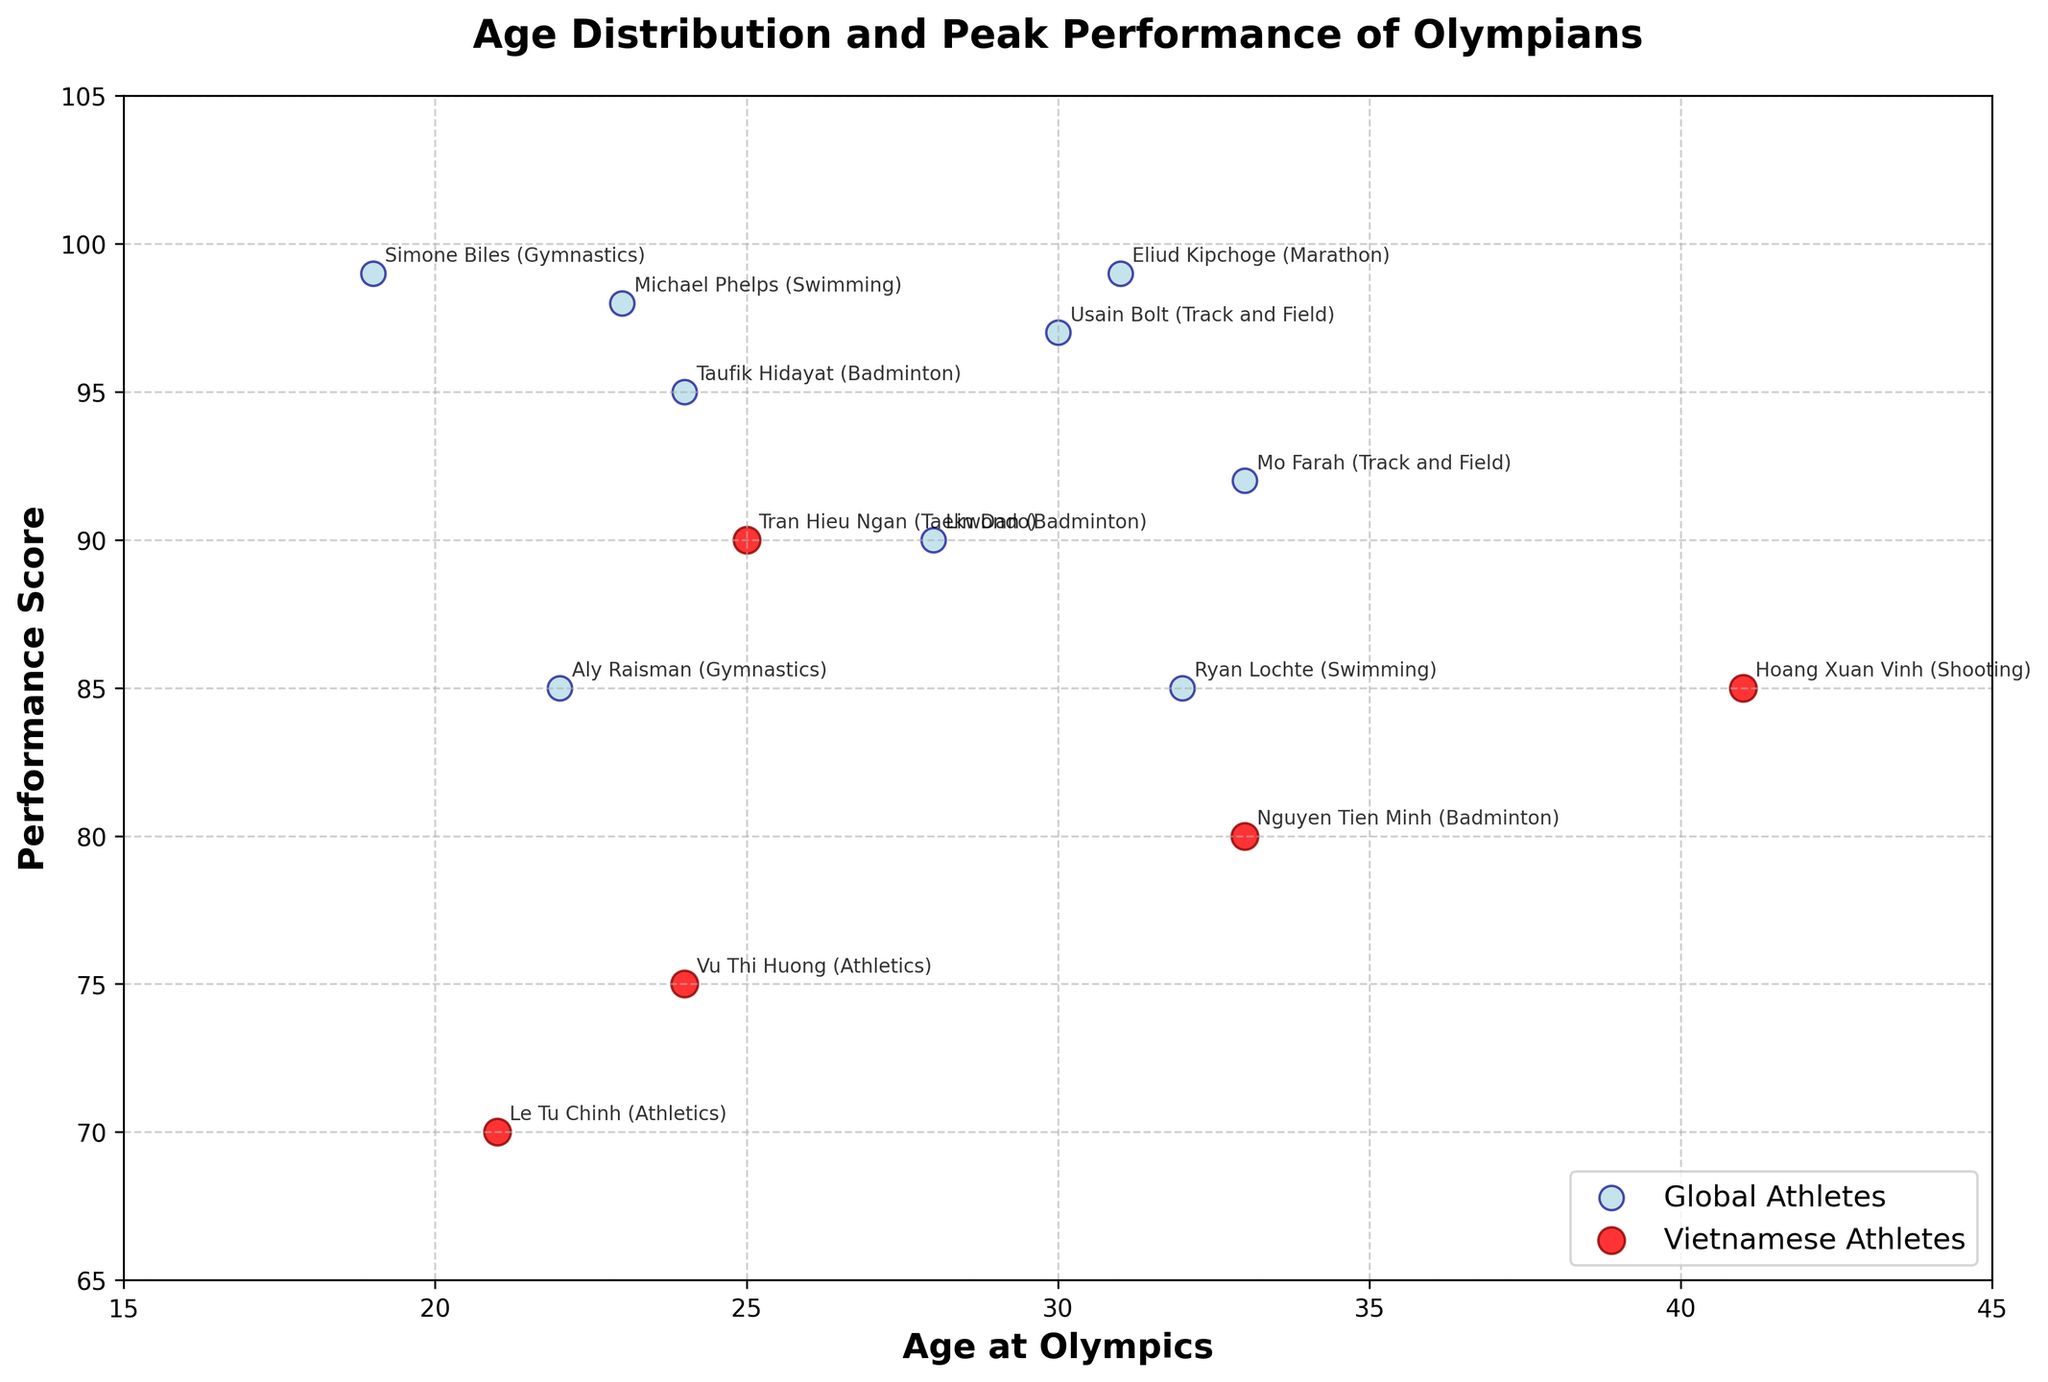What is the title of the plot? Look at the top center of the plot where the title is usually placed. The title reads "Age Distribution and Peak Performance of Olympians".
Answer: Age Distribution and Peak Performance of Olympians How many Vietnamese athletes are included in the plot? Count the number of red data points on the scatter plot, as they represent Vietnamese athletes. There are 5 red points.
Answer: 5 Which athlete has the highest performance score? Observe the y-axis (Performance Score) and identify the highest point on the plot. The athlete annotated near the highest score (99) is Simone Biles (USA) in Gymnastics.
Answer: Simone Biles How does the average age of Vietnamese athletes compare with the average age of other global athletes? Calculate the mean age of the Vietnamese athletes (33, 41, 25, 21, 24) and compare it to the mean age of the non-Vietnamese athletes (23, 19, 30, 33, 24, 28, 22, 31, 32). The average age of Vietnamese athletes is (33+41+25+21+24)/5 = 28.8. The average age of other global athletes is (23+19+30+33+24+28+22+31+32)/9 = 27.8.
Answer: Higher What sports do the Vietnamese athletes in the plot participate in? Examine the annotations next to the red data points (representing Vietnamese athletes) and note the sports listed: Badminton, Shooting, Taekwondo, and Athletics (twice).
Answer: Badminton, Shooting, Taekwondo, and Athletics Which Vietnamese athlete has the highest performance score? Identify the highest positioned red data point on the y-axis (Performance Score) and note the athlete's name and sport. Tran Hieu Ngan (Taekwondo) has the highest score (90).
Answer: Tran Hieu Ngan Is there any Vietnamese athlete older than 40 years competing? Check the red data points and annotations for ages greater than 40. Hoang Xuan Vinh (Shooting) at age 41 is older than 40.
Answer: Yes What is the average performance score of all athletes? Calculate the mean of the Performance Scores for all athletes. Sum the scores (80+85+90+70+75+98+99+97+92+95+90+85+99+85) and divide by the number of athletes (14). Average score = 1240/14 = 88.57.
Answer: 88.57 How many athletes are annotated with a performance score of 90 or above? Count the data points positioned at or above the 90 mark on the y-axis. The athletes are Tran Hieu Ngan, Michael Phelps, Simone Biles, Usain Bolt, Mo Farah, Taufik Hidayat, Lin Dan, and Eliud Kipchoge (8 in total).
Answer: 8 